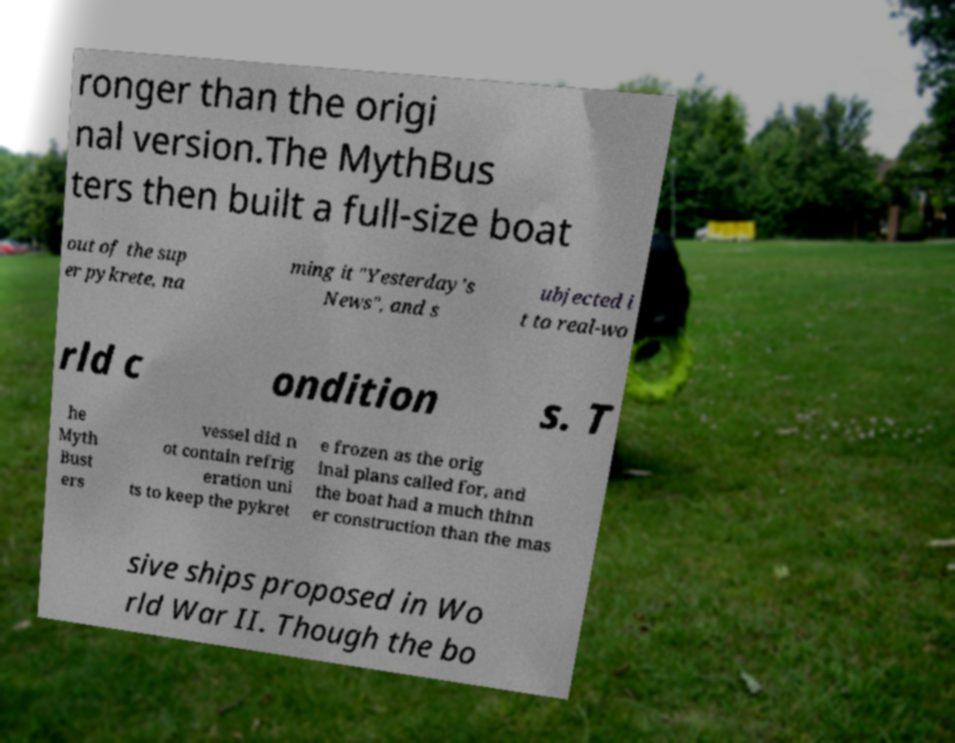Please identify and transcribe the text found in this image. ronger than the origi nal version.The MythBus ters then built a full-size boat out of the sup er pykrete, na ming it "Yesterday's News", and s ubjected i t to real-wo rld c ondition s. T he Myth Bust ers vessel did n ot contain refrig eration uni ts to keep the pykret e frozen as the orig inal plans called for, and the boat had a much thinn er construction than the mas sive ships proposed in Wo rld War II. Though the bo 